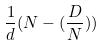Convert formula to latex. <formula><loc_0><loc_0><loc_500><loc_500>\frac { 1 } { d } ( N - ( \frac { D } { N } ) )</formula> 